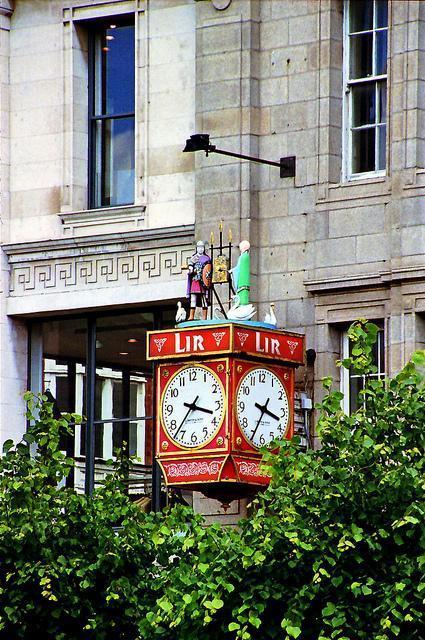How many clocks are in the photo?
Give a very brief answer. 2. 